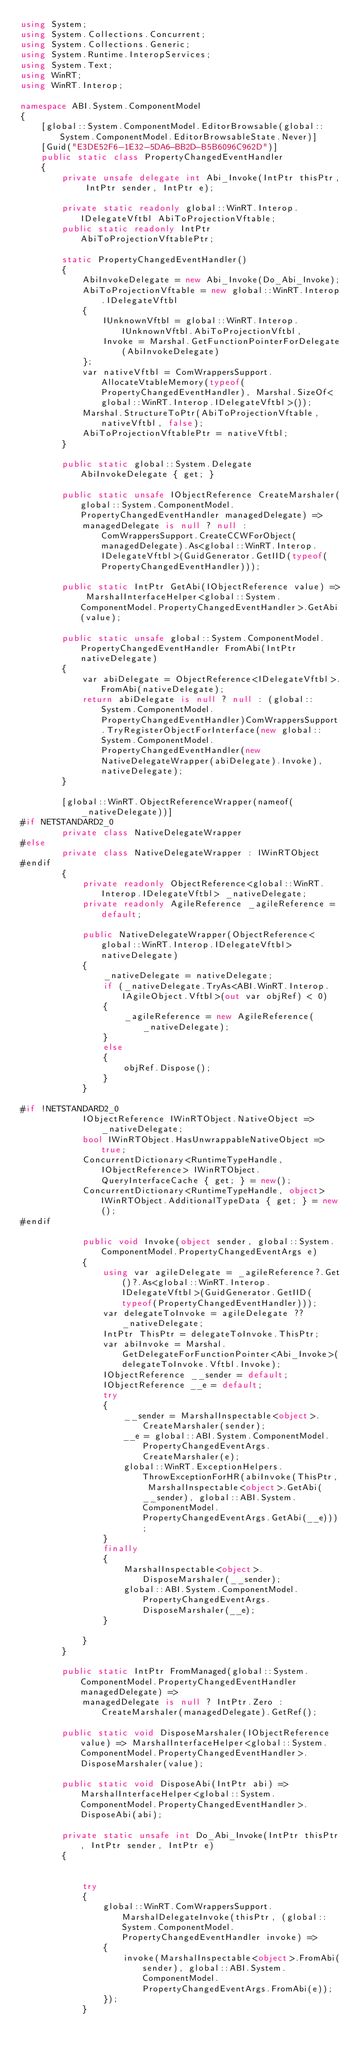<code> <loc_0><loc_0><loc_500><loc_500><_C#_>using System;
using System.Collections.Concurrent;
using System.Collections.Generic;
using System.Runtime.InteropServices;
using System.Text;
using WinRT;
using WinRT.Interop;

namespace ABI.System.ComponentModel
{
    [global::System.ComponentModel.EditorBrowsable(global::System.ComponentModel.EditorBrowsableState.Never)]
    [Guid("E3DE52F6-1E32-5DA6-BB2D-B5B6096C962D")]
    public static class PropertyChangedEventHandler
    {
        private unsafe delegate int Abi_Invoke(IntPtr thisPtr, IntPtr sender, IntPtr e);

        private static readonly global::WinRT.Interop.IDelegateVftbl AbiToProjectionVftable;
        public static readonly IntPtr AbiToProjectionVftablePtr;

        static PropertyChangedEventHandler()
        {
            AbiInvokeDelegate = new Abi_Invoke(Do_Abi_Invoke);
            AbiToProjectionVftable = new global::WinRT.Interop.IDelegateVftbl
            {
                IUnknownVftbl = global::WinRT.Interop.IUnknownVftbl.AbiToProjectionVftbl,
                Invoke = Marshal.GetFunctionPointerForDelegate(AbiInvokeDelegate)
            };
            var nativeVftbl = ComWrappersSupport.AllocateVtableMemory(typeof(PropertyChangedEventHandler), Marshal.SizeOf<global::WinRT.Interop.IDelegateVftbl>());
            Marshal.StructureToPtr(AbiToProjectionVftable, nativeVftbl, false);
            AbiToProjectionVftablePtr = nativeVftbl;
        }

        public static global::System.Delegate AbiInvokeDelegate { get; }

        public static unsafe IObjectReference CreateMarshaler(global::System.ComponentModel.PropertyChangedEventHandler managedDelegate) =>
            managedDelegate is null ? null : ComWrappersSupport.CreateCCWForObject(managedDelegate).As<global::WinRT.Interop.IDelegateVftbl>(GuidGenerator.GetIID(typeof(PropertyChangedEventHandler)));

        public static IntPtr GetAbi(IObjectReference value) => MarshalInterfaceHelper<global::System.ComponentModel.PropertyChangedEventHandler>.GetAbi(value);

        public static unsafe global::System.ComponentModel.PropertyChangedEventHandler FromAbi(IntPtr nativeDelegate)
        {
            var abiDelegate = ObjectReference<IDelegateVftbl>.FromAbi(nativeDelegate);
            return abiDelegate is null ? null : (global::System.ComponentModel.PropertyChangedEventHandler)ComWrappersSupport.TryRegisterObjectForInterface(new global::System.ComponentModel.PropertyChangedEventHandler(new NativeDelegateWrapper(abiDelegate).Invoke), nativeDelegate);
        }

        [global::WinRT.ObjectReferenceWrapper(nameof(_nativeDelegate))]
#if NETSTANDARD2_0
        private class NativeDelegateWrapper
#else
        private class NativeDelegateWrapper : IWinRTObject
#endif
        {
            private readonly ObjectReference<global::WinRT.Interop.IDelegateVftbl> _nativeDelegate;
            private readonly AgileReference _agileReference = default;

            public NativeDelegateWrapper(ObjectReference<global::WinRT.Interop.IDelegateVftbl> nativeDelegate)
            {
                _nativeDelegate = nativeDelegate;
                if (_nativeDelegate.TryAs<ABI.WinRT.Interop.IAgileObject.Vftbl>(out var objRef) < 0)
                {
                    _agileReference = new AgileReference(_nativeDelegate);
                }
                else
                {
                    objRef.Dispose();
                }
            }

#if !NETSTANDARD2_0
            IObjectReference IWinRTObject.NativeObject => _nativeDelegate;
            bool IWinRTObject.HasUnwrappableNativeObject => true;
            ConcurrentDictionary<RuntimeTypeHandle, IObjectReference> IWinRTObject.QueryInterfaceCache { get; } = new();
            ConcurrentDictionary<RuntimeTypeHandle, object> IWinRTObject.AdditionalTypeData { get; } = new();
#endif

            public void Invoke(object sender, global::System.ComponentModel.PropertyChangedEventArgs e)
            {
                using var agileDelegate = _agileReference?.Get()?.As<global::WinRT.Interop.IDelegateVftbl>(GuidGenerator.GetIID(typeof(PropertyChangedEventHandler)));
                var delegateToInvoke = agileDelegate ?? _nativeDelegate;
                IntPtr ThisPtr = delegateToInvoke.ThisPtr;
                var abiInvoke = Marshal.GetDelegateForFunctionPointer<Abi_Invoke>(delegateToInvoke.Vftbl.Invoke);
                IObjectReference __sender = default;
                IObjectReference __e = default;
                try
                {
                    __sender = MarshalInspectable<object>.CreateMarshaler(sender);
                    __e = global::ABI.System.ComponentModel.PropertyChangedEventArgs.CreateMarshaler(e);
                    global::WinRT.ExceptionHelpers.ThrowExceptionForHR(abiInvoke(ThisPtr, MarshalInspectable<object>.GetAbi(__sender), global::ABI.System.ComponentModel.PropertyChangedEventArgs.GetAbi(__e)));
                }
                finally
                {
                    MarshalInspectable<object>.DisposeMarshaler(__sender);
                    global::ABI.System.ComponentModel.PropertyChangedEventArgs.DisposeMarshaler(__e);
                }

            }
        }

        public static IntPtr FromManaged(global::System.ComponentModel.PropertyChangedEventHandler managedDelegate) =>
            managedDelegate is null ? IntPtr.Zero : CreateMarshaler(managedDelegate).GetRef();

        public static void DisposeMarshaler(IObjectReference value) => MarshalInterfaceHelper<global::System.ComponentModel.PropertyChangedEventHandler>.DisposeMarshaler(value);

        public static void DisposeAbi(IntPtr abi) => MarshalInterfaceHelper<global::System.ComponentModel.PropertyChangedEventHandler>.DisposeAbi(abi);

        private static unsafe int Do_Abi_Invoke(IntPtr thisPtr, IntPtr sender, IntPtr e)
        {


            try
            {
                global::WinRT.ComWrappersSupport.MarshalDelegateInvoke(thisPtr, (global::System.ComponentModel.PropertyChangedEventHandler invoke) =>
                {
                    invoke(MarshalInspectable<object>.FromAbi(sender), global::ABI.System.ComponentModel.PropertyChangedEventArgs.FromAbi(e));
                });
            }</code> 